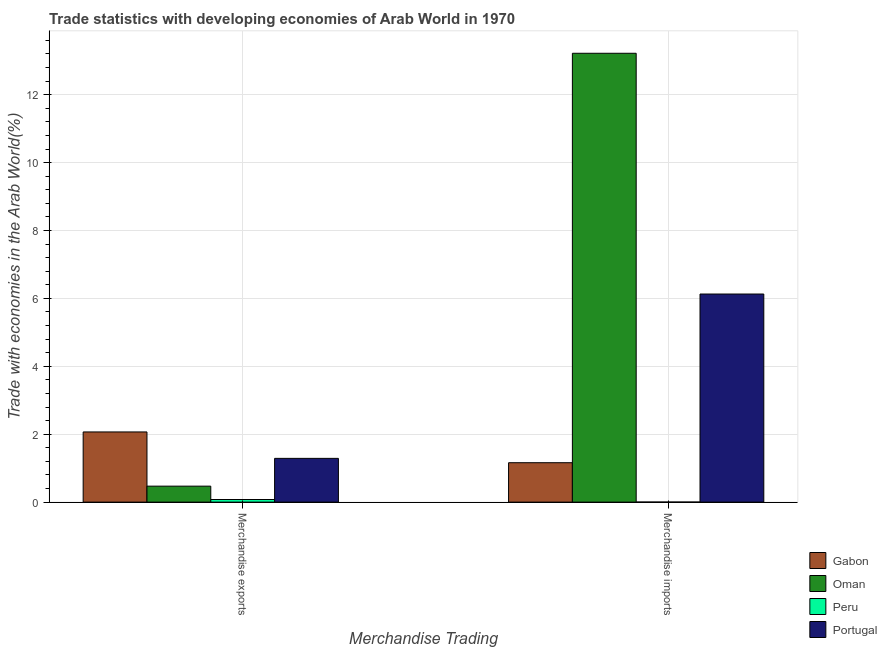How many different coloured bars are there?
Your response must be concise. 4. How many groups of bars are there?
Make the answer very short. 2. Are the number of bars per tick equal to the number of legend labels?
Keep it short and to the point. Yes. How many bars are there on the 1st tick from the left?
Offer a terse response. 4. How many bars are there on the 2nd tick from the right?
Offer a very short reply. 4. What is the merchandise imports in Gabon?
Provide a short and direct response. 1.16. Across all countries, what is the maximum merchandise imports?
Provide a short and direct response. 13.22. Across all countries, what is the minimum merchandise imports?
Offer a very short reply. 0. In which country was the merchandise exports maximum?
Your answer should be very brief. Gabon. In which country was the merchandise exports minimum?
Ensure brevity in your answer.  Peru. What is the total merchandise exports in the graph?
Offer a terse response. 3.9. What is the difference between the merchandise exports in Oman and that in Gabon?
Ensure brevity in your answer.  -1.6. What is the difference between the merchandise exports in Peru and the merchandise imports in Gabon?
Offer a terse response. -1.08. What is the average merchandise exports per country?
Ensure brevity in your answer.  0.98. What is the difference between the merchandise exports and merchandise imports in Gabon?
Ensure brevity in your answer.  0.91. In how many countries, is the merchandise exports greater than 3.2 %?
Make the answer very short. 0. What is the ratio of the merchandise imports in Peru to that in Portugal?
Provide a short and direct response. 0. What does the 2nd bar from the left in Merchandise imports represents?
Ensure brevity in your answer.  Oman. What does the 3rd bar from the right in Merchandise exports represents?
Keep it short and to the point. Oman. How many bars are there?
Offer a very short reply. 8. Are all the bars in the graph horizontal?
Offer a very short reply. No. What is the difference between two consecutive major ticks on the Y-axis?
Your answer should be compact. 2. Are the values on the major ticks of Y-axis written in scientific E-notation?
Provide a short and direct response. No. Does the graph contain any zero values?
Give a very brief answer. No. Where does the legend appear in the graph?
Ensure brevity in your answer.  Bottom right. How many legend labels are there?
Provide a succinct answer. 4. What is the title of the graph?
Provide a succinct answer. Trade statistics with developing economies of Arab World in 1970. What is the label or title of the X-axis?
Provide a short and direct response. Merchandise Trading. What is the label or title of the Y-axis?
Offer a very short reply. Trade with economies in the Arab World(%). What is the Trade with economies in the Arab World(%) of Gabon in Merchandise exports?
Ensure brevity in your answer.  2.07. What is the Trade with economies in the Arab World(%) in Oman in Merchandise exports?
Make the answer very short. 0.47. What is the Trade with economies in the Arab World(%) of Peru in Merchandise exports?
Your answer should be very brief. 0.08. What is the Trade with economies in the Arab World(%) of Portugal in Merchandise exports?
Give a very brief answer. 1.29. What is the Trade with economies in the Arab World(%) of Gabon in Merchandise imports?
Your answer should be compact. 1.16. What is the Trade with economies in the Arab World(%) of Oman in Merchandise imports?
Offer a terse response. 13.22. What is the Trade with economies in the Arab World(%) of Peru in Merchandise imports?
Provide a short and direct response. 0. What is the Trade with economies in the Arab World(%) in Portugal in Merchandise imports?
Provide a short and direct response. 6.13. Across all Merchandise Trading, what is the maximum Trade with economies in the Arab World(%) in Gabon?
Provide a succinct answer. 2.07. Across all Merchandise Trading, what is the maximum Trade with economies in the Arab World(%) in Oman?
Provide a succinct answer. 13.22. Across all Merchandise Trading, what is the maximum Trade with economies in the Arab World(%) of Peru?
Provide a succinct answer. 0.08. Across all Merchandise Trading, what is the maximum Trade with economies in the Arab World(%) in Portugal?
Your response must be concise. 6.13. Across all Merchandise Trading, what is the minimum Trade with economies in the Arab World(%) of Gabon?
Your answer should be very brief. 1.16. Across all Merchandise Trading, what is the minimum Trade with economies in the Arab World(%) of Oman?
Provide a succinct answer. 0.47. Across all Merchandise Trading, what is the minimum Trade with economies in the Arab World(%) in Peru?
Provide a succinct answer. 0. Across all Merchandise Trading, what is the minimum Trade with economies in the Arab World(%) of Portugal?
Keep it short and to the point. 1.29. What is the total Trade with economies in the Arab World(%) of Gabon in the graph?
Provide a short and direct response. 3.23. What is the total Trade with economies in the Arab World(%) in Oman in the graph?
Provide a succinct answer. 13.69. What is the total Trade with economies in the Arab World(%) in Peru in the graph?
Offer a very short reply. 0.08. What is the total Trade with economies in the Arab World(%) of Portugal in the graph?
Ensure brevity in your answer.  7.42. What is the difference between the Trade with economies in the Arab World(%) in Gabon in Merchandise exports and that in Merchandise imports?
Your answer should be very brief. 0.91. What is the difference between the Trade with economies in the Arab World(%) in Oman in Merchandise exports and that in Merchandise imports?
Your answer should be compact. -12.75. What is the difference between the Trade with economies in the Arab World(%) in Peru in Merchandise exports and that in Merchandise imports?
Give a very brief answer. 0.08. What is the difference between the Trade with economies in the Arab World(%) in Portugal in Merchandise exports and that in Merchandise imports?
Keep it short and to the point. -4.84. What is the difference between the Trade with economies in the Arab World(%) of Gabon in Merchandise exports and the Trade with economies in the Arab World(%) of Oman in Merchandise imports?
Offer a terse response. -11.15. What is the difference between the Trade with economies in the Arab World(%) of Gabon in Merchandise exports and the Trade with economies in the Arab World(%) of Peru in Merchandise imports?
Offer a terse response. 2.07. What is the difference between the Trade with economies in the Arab World(%) in Gabon in Merchandise exports and the Trade with economies in the Arab World(%) in Portugal in Merchandise imports?
Offer a very short reply. -4.06. What is the difference between the Trade with economies in the Arab World(%) in Oman in Merchandise exports and the Trade with economies in the Arab World(%) in Peru in Merchandise imports?
Offer a terse response. 0.47. What is the difference between the Trade with economies in the Arab World(%) in Oman in Merchandise exports and the Trade with economies in the Arab World(%) in Portugal in Merchandise imports?
Your response must be concise. -5.66. What is the difference between the Trade with economies in the Arab World(%) in Peru in Merchandise exports and the Trade with economies in the Arab World(%) in Portugal in Merchandise imports?
Give a very brief answer. -6.05. What is the average Trade with economies in the Arab World(%) in Gabon per Merchandise Trading?
Offer a very short reply. 1.61. What is the average Trade with economies in the Arab World(%) of Oman per Merchandise Trading?
Your answer should be very brief. 6.85. What is the average Trade with economies in the Arab World(%) of Peru per Merchandise Trading?
Your answer should be compact. 0.04. What is the average Trade with economies in the Arab World(%) of Portugal per Merchandise Trading?
Ensure brevity in your answer.  3.71. What is the difference between the Trade with economies in the Arab World(%) of Gabon and Trade with economies in the Arab World(%) of Oman in Merchandise exports?
Your answer should be compact. 1.6. What is the difference between the Trade with economies in the Arab World(%) in Gabon and Trade with economies in the Arab World(%) in Peru in Merchandise exports?
Keep it short and to the point. 1.99. What is the difference between the Trade with economies in the Arab World(%) of Gabon and Trade with economies in the Arab World(%) of Portugal in Merchandise exports?
Your response must be concise. 0.78. What is the difference between the Trade with economies in the Arab World(%) in Oman and Trade with economies in the Arab World(%) in Peru in Merchandise exports?
Your answer should be compact. 0.39. What is the difference between the Trade with economies in the Arab World(%) of Oman and Trade with economies in the Arab World(%) of Portugal in Merchandise exports?
Give a very brief answer. -0.82. What is the difference between the Trade with economies in the Arab World(%) of Peru and Trade with economies in the Arab World(%) of Portugal in Merchandise exports?
Give a very brief answer. -1.21. What is the difference between the Trade with economies in the Arab World(%) of Gabon and Trade with economies in the Arab World(%) of Oman in Merchandise imports?
Make the answer very short. -12.06. What is the difference between the Trade with economies in the Arab World(%) of Gabon and Trade with economies in the Arab World(%) of Peru in Merchandise imports?
Give a very brief answer. 1.16. What is the difference between the Trade with economies in the Arab World(%) in Gabon and Trade with economies in the Arab World(%) in Portugal in Merchandise imports?
Provide a short and direct response. -4.97. What is the difference between the Trade with economies in the Arab World(%) in Oman and Trade with economies in the Arab World(%) in Peru in Merchandise imports?
Provide a succinct answer. 13.22. What is the difference between the Trade with economies in the Arab World(%) in Oman and Trade with economies in the Arab World(%) in Portugal in Merchandise imports?
Offer a terse response. 7.09. What is the difference between the Trade with economies in the Arab World(%) of Peru and Trade with economies in the Arab World(%) of Portugal in Merchandise imports?
Your answer should be compact. -6.13. What is the ratio of the Trade with economies in the Arab World(%) in Gabon in Merchandise exports to that in Merchandise imports?
Provide a short and direct response. 1.78. What is the ratio of the Trade with economies in the Arab World(%) in Oman in Merchandise exports to that in Merchandise imports?
Keep it short and to the point. 0.04. What is the ratio of the Trade with economies in the Arab World(%) of Peru in Merchandise exports to that in Merchandise imports?
Your response must be concise. 47.84. What is the ratio of the Trade with economies in the Arab World(%) in Portugal in Merchandise exports to that in Merchandise imports?
Your response must be concise. 0.21. What is the difference between the highest and the second highest Trade with economies in the Arab World(%) in Gabon?
Provide a succinct answer. 0.91. What is the difference between the highest and the second highest Trade with economies in the Arab World(%) of Oman?
Offer a very short reply. 12.75. What is the difference between the highest and the second highest Trade with economies in the Arab World(%) in Peru?
Give a very brief answer. 0.08. What is the difference between the highest and the second highest Trade with economies in the Arab World(%) of Portugal?
Offer a terse response. 4.84. What is the difference between the highest and the lowest Trade with economies in the Arab World(%) in Gabon?
Give a very brief answer. 0.91. What is the difference between the highest and the lowest Trade with economies in the Arab World(%) in Oman?
Your response must be concise. 12.75. What is the difference between the highest and the lowest Trade with economies in the Arab World(%) of Peru?
Your answer should be very brief. 0.08. What is the difference between the highest and the lowest Trade with economies in the Arab World(%) in Portugal?
Provide a succinct answer. 4.84. 